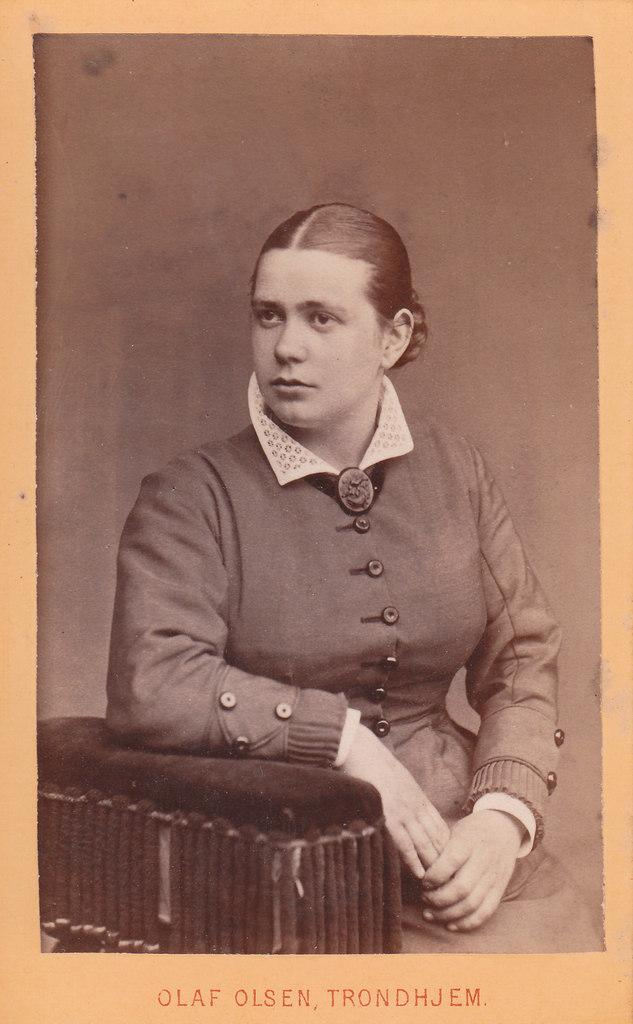What is the main subject of the image? There is a photograph in the image. What can be seen in the photograph? The photograph contains a girl. What type of sail is the girl holding in the photograph? There is no sail present in the photograph; it only contains a girl. 